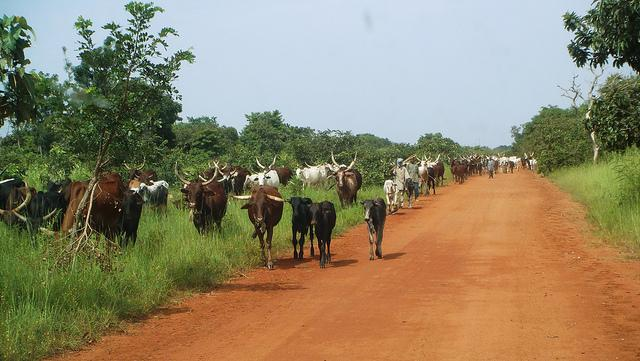What do many of these animals have?

Choices:
A) horns
B) wings
C) quills
D) talons horns 